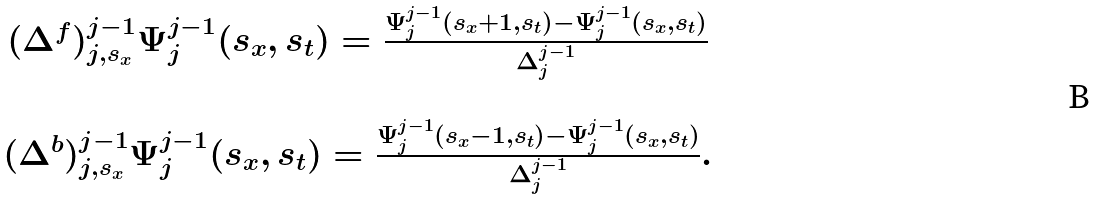<formula> <loc_0><loc_0><loc_500><loc_500>\begin{array} { c } ( \Delta ^ { f } ) ^ { j - 1 } _ { j , s _ { x } } \Psi ^ { j - 1 } _ { j } ( s _ { x } , s _ { t } ) = \frac { \Psi ^ { j - 1 } _ { j } ( s _ { x } + 1 , s _ { t } ) - \Psi ^ { j - 1 } _ { j } ( s _ { x } , s _ { t } ) } { \Delta ^ { j - 1 } _ { j } } \\ \\ ( \Delta ^ { b } ) ^ { j - 1 } _ { j , s _ { x } } \Psi ^ { j - 1 } _ { j } ( s _ { x } , s _ { t } ) = \frac { \Psi ^ { j - 1 } _ { j } ( s _ { x } - 1 , s _ { t } ) - \Psi ^ { j - 1 } _ { j } ( s _ { x } , s _ { t } ) } { \Delta ^ { j - 1 } _ { j } } . \end{array}</formula> 